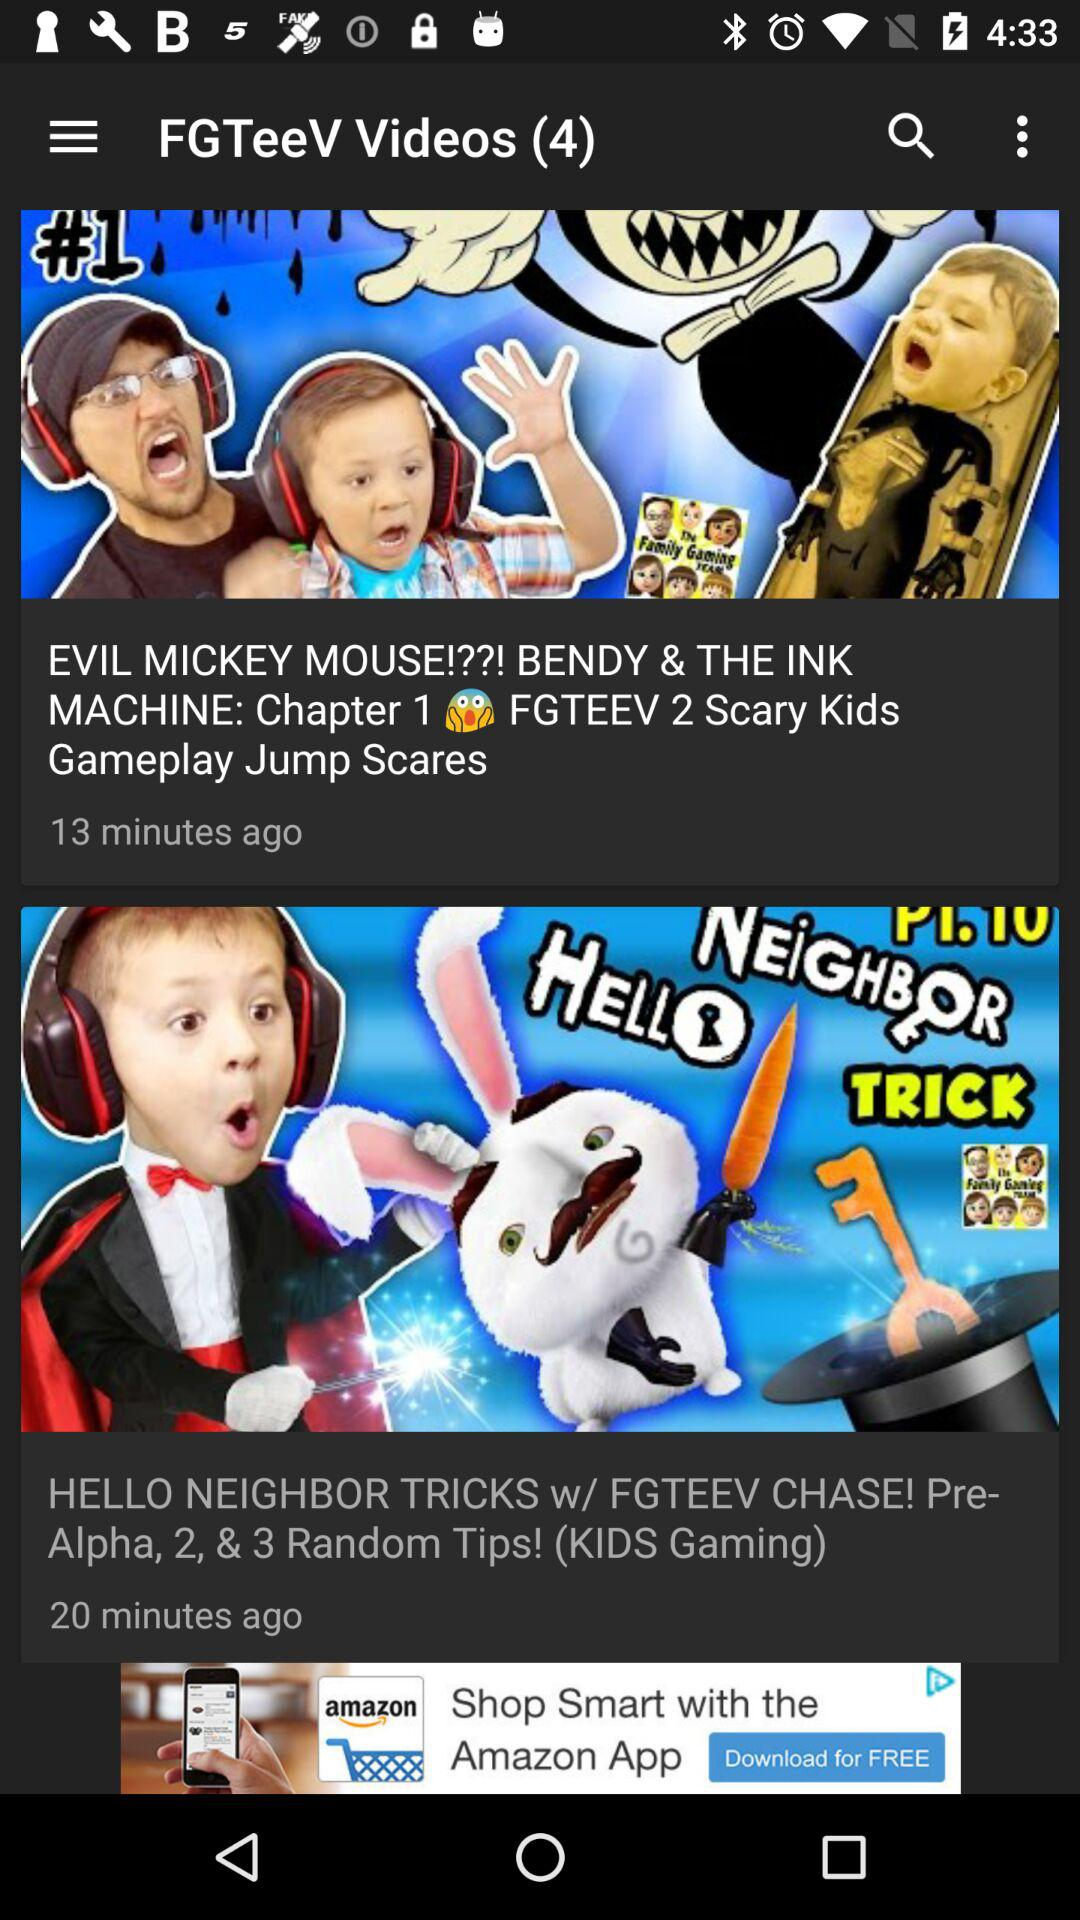How long is the Evil Mickey Monkey video?
When the provided information is insufficient, respond with <no answer>. <no answer> 